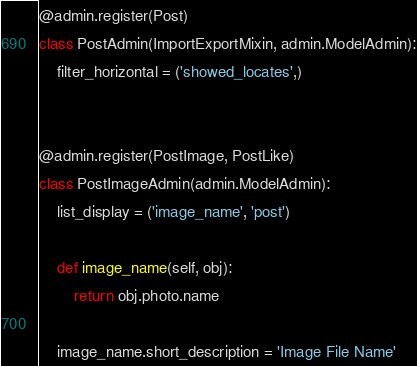Convert code to text. <code><loc_0><loc_0><loc_500><loc_500><_Python_>
@admin.register(Post)
class PostAdmin(ImportExportMixin, admin.ModelAdmin):
    filter_horizontal = ('showed_locates',)


@admin.register(PostImage, PostLike)
class PostImageAdmin(admin.ModelAdmin):
    list_display = ('image_name', 'post')

    def image_name(self, obj):
        return obj.photo.name

    image_name.short_description = 'Image File Name'
</code> 